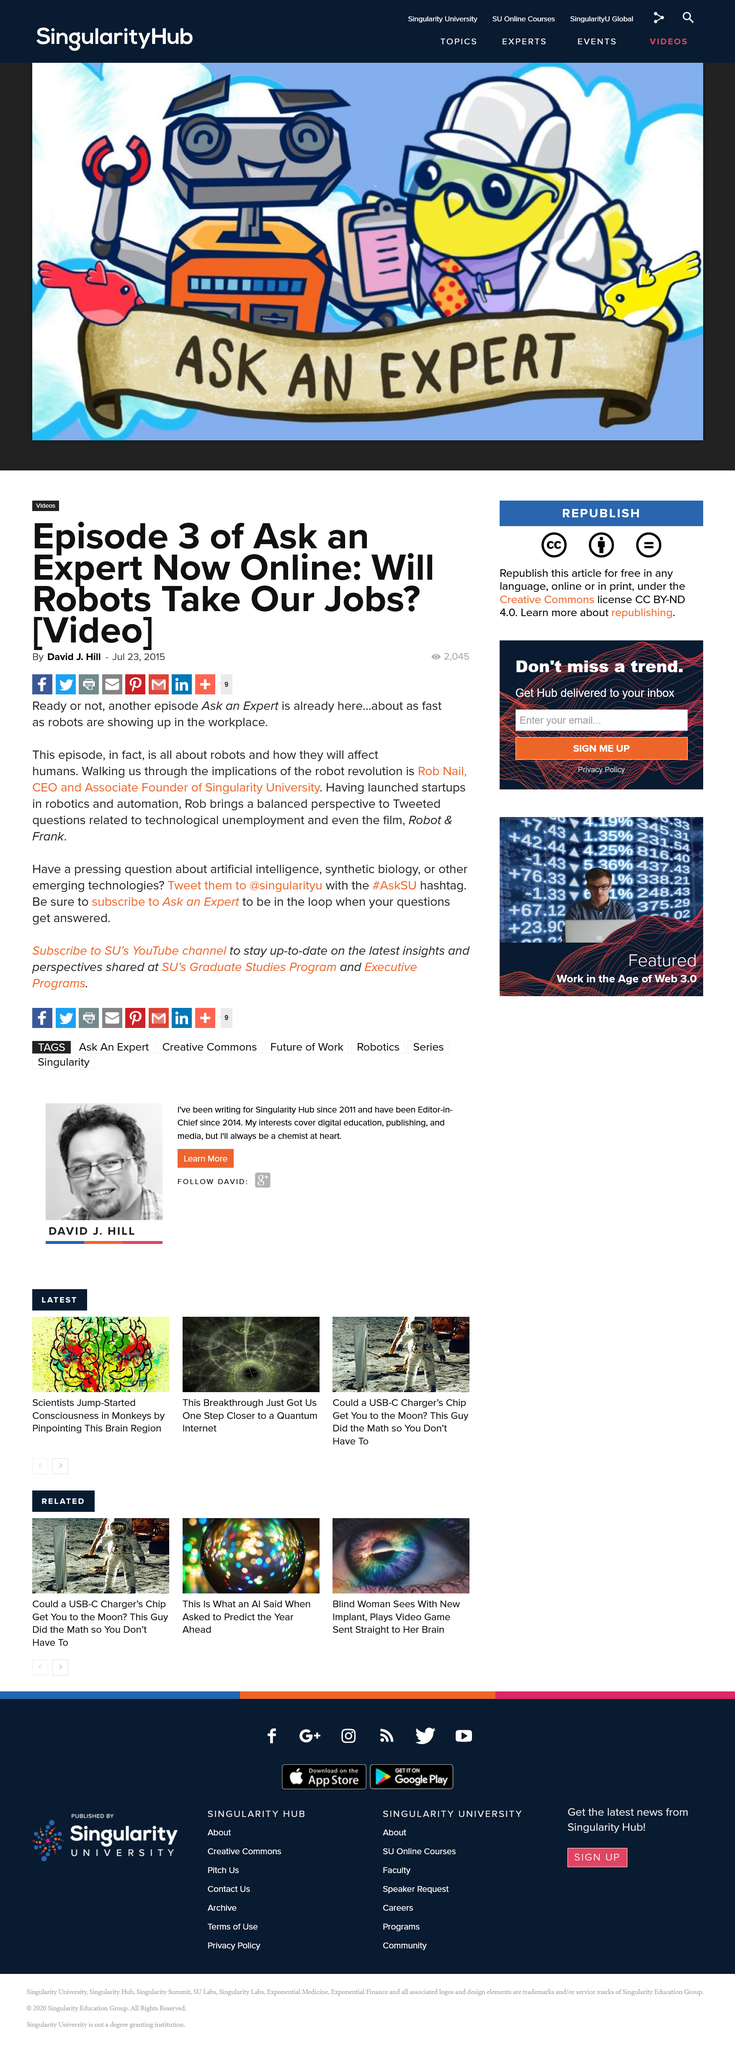Point out several critical features in this image. The title of this article asks the question of whether robots will take people's jobs. This article discusses episode three of the television show 'Ask An Expert'. The speaker announces that in this episode, Rob Nail will be explaining the consequences of the robot revolution. 